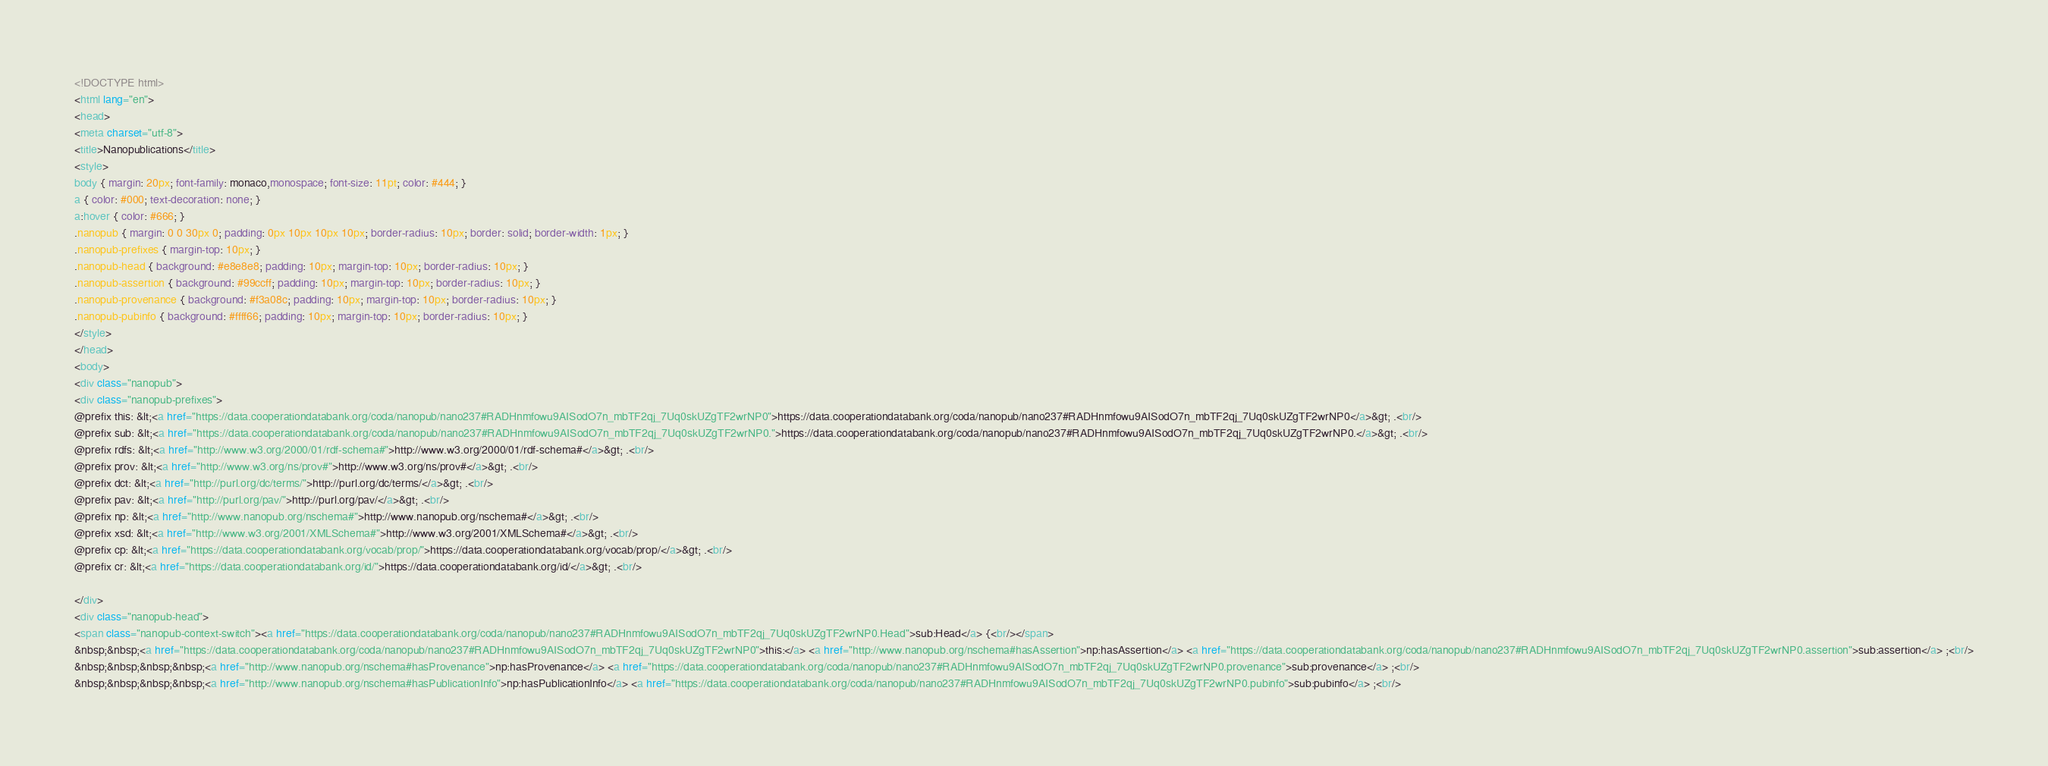Convert code to text. <code><loc_0><loc_0><loc_500><loc_500><_HTML_><!DOCTYPE html>
<html lang="en">
<head>
<meta charset="utf-8">
<title>Nanopublications</title>
<style>
body { margin: 20px; font-family: monaco,monospace; font-size: 11pt; color: #444; }
a { color: #000; text-decoration: none; }
a:hover { color: #666; }
.nanopub { margin: 0 0 30px 0; padding: 0px 10px 10px 10px; border-radius: 10px; border: solid; border-width: 1px; }
.nanopub-prefixes { margin-top: 10px; }
.nanopub-head { background: #e8e8e8; padding: 10px; margin-top: 10px; border-radius: 10px; }
.nanopub-assertion { background: #99ccff; padding: 10px; margin-top: 10px; border-radius: 10px; }
.nanopub-provenance { background: #f3a08c; padding: 10px; margin-top: 10px; border-radius: 10px; }
.nanopub-pubinfo { background: #ffff66; padding: 10px; margin-top: 10px; border-radius: 10px; }
</style>
</head>
<body>
<div class="nanopub">
<div class="nanopub-prefixes">
@prefix this: &lt;<a href="https://data.cooperationdatabank.org/coda/nanopub/nano237#RADHnmfowu9AISodO7n_mbTF2qj_7Uq0skUZgTF2wrNP0">https://data.cooperationdatabank.org/coda/nanopub/nano237#RADHnmfowu9AISodO7n_mbTF2qj_7Uq0skUZgTF2wrNP0</a>&gt; .<br/>
@prefix sub: &lt;<a href="https://data.cooperationdatabank.org/coda/nanopub/nano237#RADHnmfowu9AISodO7n_mbTF2qj_7Uq0skUZgTF2wrNP0.">https://data.cooperationdatabank.org/coda/nanopub/nano237#RADHnmfowu9AISodO7n_mbTF2qj_7Uq0skUZgTF2wrNP0.</a>&gt; .<br/>
@prefix rdfs: &lt;<a href="http://www.w3.org/2000/01/rdf-schema#">http://www.w3.org/2000/01/rdf-schema#</a>&gt; .<br/>
@prefix prov: &lt;<a href="http://www.w3.org/ns/prov#">http://www.w3.org/ns/prov#</a>&gt; .<br/>
@prefix dct: &lt;<a href="http://purl.org/dc/terms/">http://purl.org/dc/terms/</a>&gt; .<br/>
@prefix pav: &lt;<a href="http://purl.org/pav/">http://purl.org/pav/</a>&gt; .<br/>
@prefix np: &lt;<a href="http://www.nanopub.org/nschema#">http://www.nanopub.org/nschema#</a>&gt; .<br/>
@prefix xsd: &lt;<a href="http://www.w3.org/2001/XMLSchema#">http://www.w3.org/2001/XMLSchema#</a>&gt; .<br/>
@prefix cp: &lt;<a href="https://data.cooperationdatabank.org/vocab/prop/">https://data.cooperationdatabank.org/vocab/prop/</a>&gt; .<br/>
@prefix cr: &lt;<a href="https://data.cooperationdatabank.org/id/">https://data.cooperationdatabank.org/id/</a>&gt; .<br/>

</div>
<div class="nanopub-head">
<span class="nanopub-context-switch"><a href="https://data.cooperationdatabank.org/coda/nanopub/nano237#RADHnmfowu9AISodO7n_mbTF2qj_7Uq0skUZgTF2wrNP0.Head">sub:Head</a> {<br/></span>
&nbsp;&nbsp;<a href="https://data.cooperationdatabank.org/coda/nanopub/nano237#RADHnmfowu9AISodO7n_mbTF2qj_7Uq0skUZgTF2wrNP0">this:</a> <a href="http://www.nanopub.org/nschema#hasAssertion">np:hasAssertion</a> <a href="https://data.cooperationdatabank.org/coda/nanopub/nano237#RADHnmfowu9AISodO7n_mbTF2qj_7Uq0skUZgTF2wrNP0.assertion">sub:assertion</a> ;<br/>
&nbsp;&nbsp;&nbsp;&nbsp;<a href="http://www.nanopub.org/nschema#hasProvenance">np:hasProvenance</a> <a href="https://data.cooperationdatabank.org/coda/nanopub/nano237#RADHnmfowu9AISodO7n_mbTF2qj_7Uq0skUZgTF2wrNP0.provenance">sub:provenance</a> ;<br/>
&nbsp;&nbsp;&nbsp;&nbsp;<a href="http://www.nanopub.org/nschema#hasPublicationInfo">np:hasPublicationInfo</a> <a href="https://data.cooperationdatabank.org/coda/nanopub/nano237#RADHnmfowu9AISodO7n_mbTF2qj_7Uq0skUZgTF2wrNP0.pubinfo">sub:pubinfo</a> ;<br/></code> 